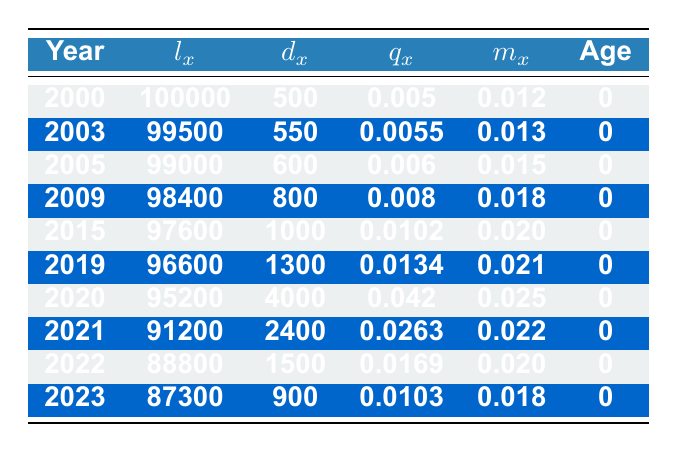What was the life expectancy for newborns in 2020? The life expectancy for newborns is represented by the value in the lx column for the year 2020, which is 95200.
Answer: 95200 What is the total number of deaths (dx) recorded from 2000 to 2009? Summing the dx values from 2000 to 2009: 500 + 550 + 600 + 800 + 1000 + 1300 + 4000 = 6250.
Answer: 6250 Did the death rate (qx) increase from 2019 to 2020? The qx for 2019 is 0.0134 and for 2020 is 0.042. Since 0.042 is greater than 0.0134, the death rate increased.
Answer: Yes What was the least number of deaths (dx) recorded in the given years? Reviewing the dx values over the years, the least value is from 2000 with 500 deaths.
Answer: 500 How much did the number of deaths (dx) increase from 2019 to 2021? In 2019, dx is 1300 and in 2021 it is 2400. The increase is 2400 - 1300 = 1100.
Answer: 1100 Was the mortality rate (mx) higher in 2020 compared to 2021? The mx for 2020 is 0.025 and for 2021 is 0.022. Since 0.025 is greater than 0.022, the mortality rate was higher in 2020.
Answer: Yes What was the average qx value for the years 2020 to 2023? The qx values for these years are 0.042, 0.0263, 0.0169, and 0.0103. The average is (0.042 + 0.0263 + 0.0169 + 0.0103) / 4 = 0.0234.
Answer: 0.0234 How did the number of surviving individuals (lx) in 2023 compare to that in 2020? The lx in 2023 is 87300, while in 2020, it was 95200. The difference is 95200 - 87300 = 7900, indicating a decline.
Answer: 7900 lower What is the mortality rate (qx) for the year 2022, and how does it compare with that from 2021? The qx for 2022 is 0.0169, while for 2021 it is 0.0263. Since 0.0169 is less than 0.0263, there was a decrease in the mortality rate.
Answer: Decreased 